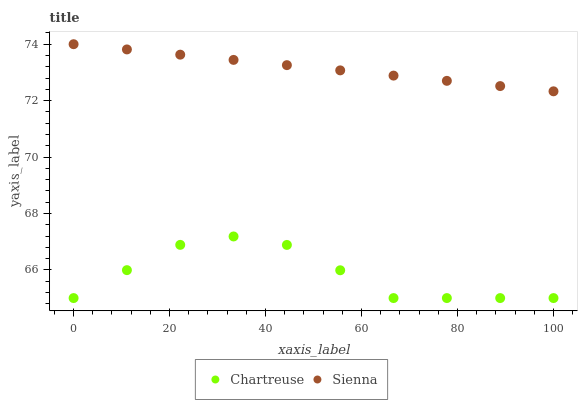Does Chartreuse have the minimum area under the curve?
Answer yes or no. Yes. Does Sienna have the maximum area under the curve?
Answer yes or no. Yes. Does Chartreuse have the maximum area under the curve?
Answer yes or no. No. Is Sienna the smoothest?
Answer yes or no. Yes. Is Chartreuse the roughest?
Answer yes or no. Yes. Is Chartreuse the smoothest?
Answer yes or no. No. Does Chartreuse have the lowest value?
Answer yes or no. Yes. Does Sienna have the highest value?
Answer yes or no. Yes. Does Chartreuse have the highest value?
Answer yes or no. No. Is Chartreuse less than Sienna?
Answer yes or no. Yes. Is Sienna greater than Chartreuse?
Answer yes or no. Yes. Does Chartreuse intersect Sienna?
Answer yes or no. No. 